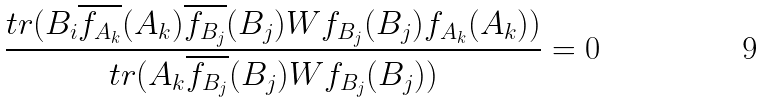Convert formula to latex. <formula><loc_0><loc_0><loc_500><loc_500>\frac { t r ( B _ { i } \overline { f _ { A _ { k } } } ( A _ { k } ) \overline { f _ { B _ { j } } } ( B _ { j } ) W f _ { B _ { j } } ( B _ { j } ) f _ { A _ { k } } ( A _ { k } ) ) } { t r ( A _ { k } \overline { f _ { B _ { j } } } ( B _ { j } ) W f _ { B _ { j } } ( B _ { j } ) ) } = 0</formula> 